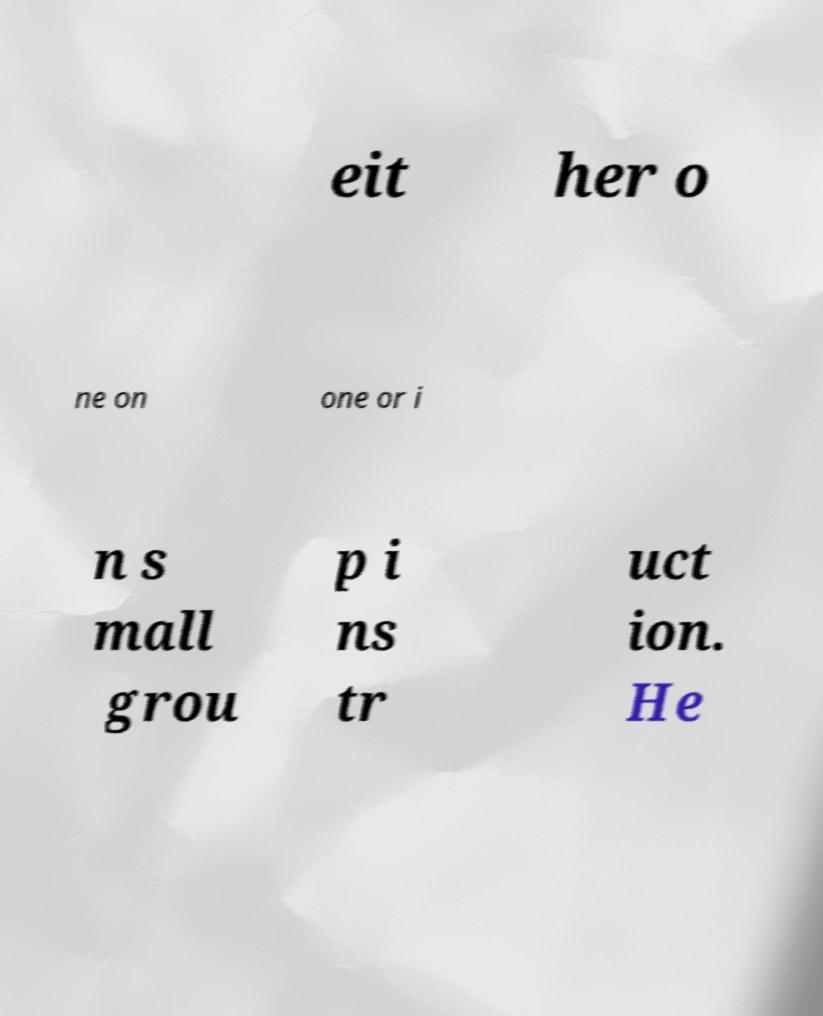Could you extract and type out the text from this image? eit her o ne on one or i n s mall grou p i ns tr uct ion. He 